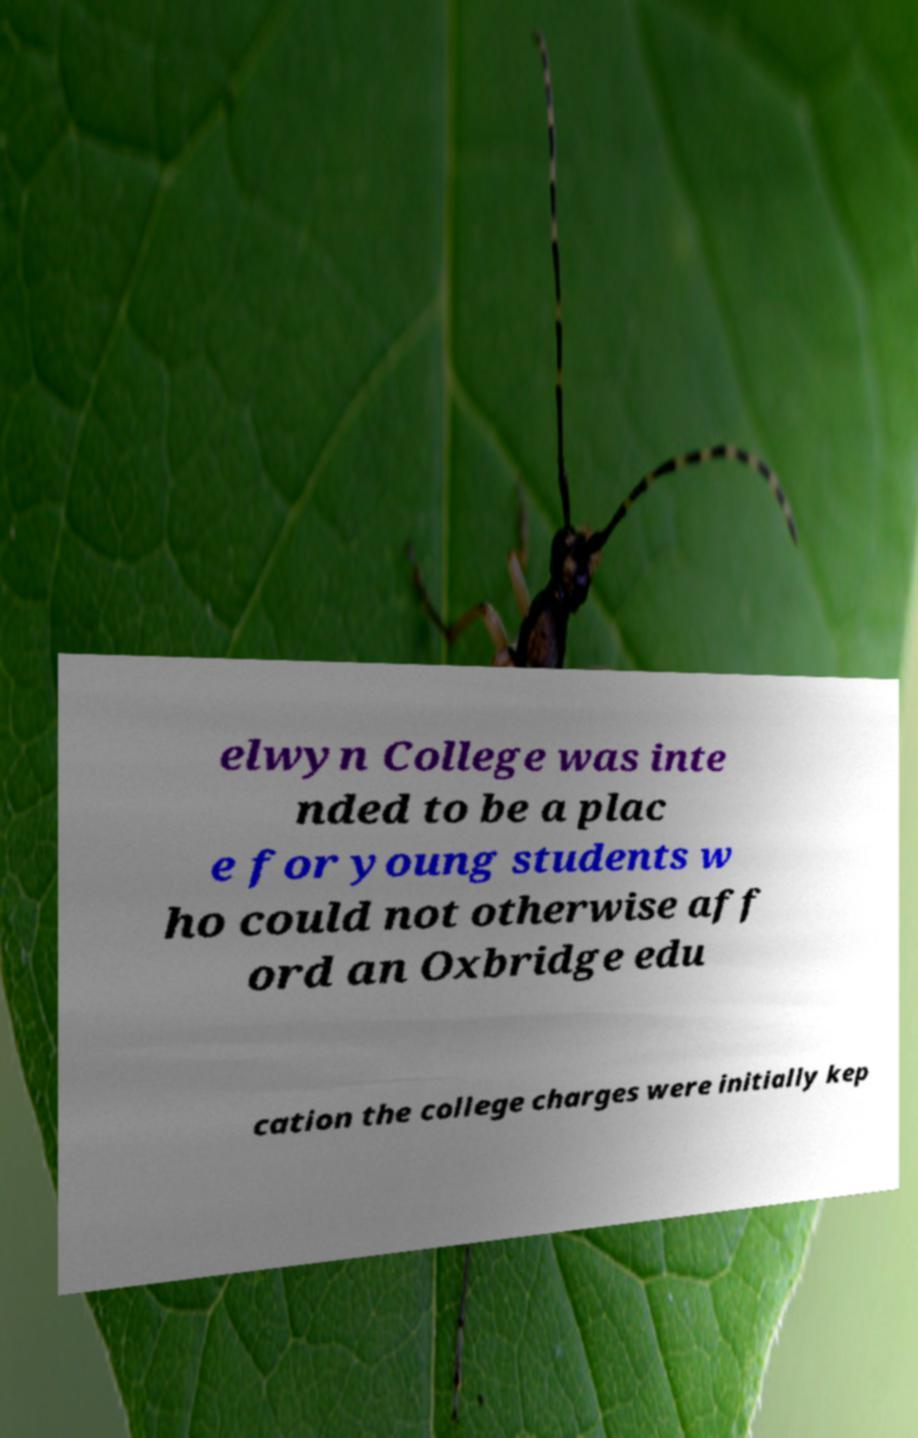What messages or text are displayed in this image? I need them in a readable, typed format. elwyn College was inte nded to be a plac e for young students w ho could not otherwise aff ord an Oxbridge edu cation the college charges were initially kep 